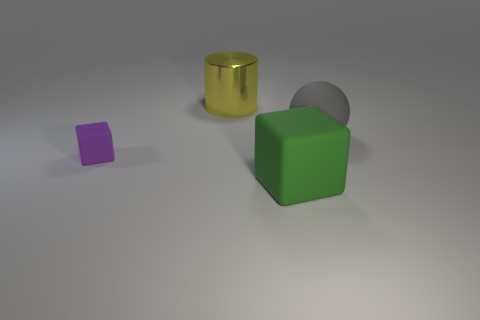There is a big matte object on the left side of the large object that is to the right of the big green matte block; what shape is it?
Give a very brief answer. Cube. What number of tiny objects are green rubber spheres or gray matte balls?
Your response must be concise. 0. How many other rubber objects are the same shape as the tiny rubber object?
Your response must be concise. 1. There is a small purple thing; does it have the same shape as the large rubber thing that is in front of the gray thing?
Your answer should be compact. Yes. How many cylinders are on the right side of the big green matte object?
Provide a succinct answer. 0. Are there any green matte things that have the same size as the yellow metallic thing?
Offer a terse response. Yes. Does the green object that is in front of the large gray thing have the same shape as the tiny rubber thing?
Offer a very short reply. Yes. What is the color of the large sphere?
Your answer should be very brief. Gray. Is there a green matte object?
Your answer should be very brief. Yes. There is a gray object that is the same material as the purple cube; what size is it?
Your answer should be very brief. Large. 